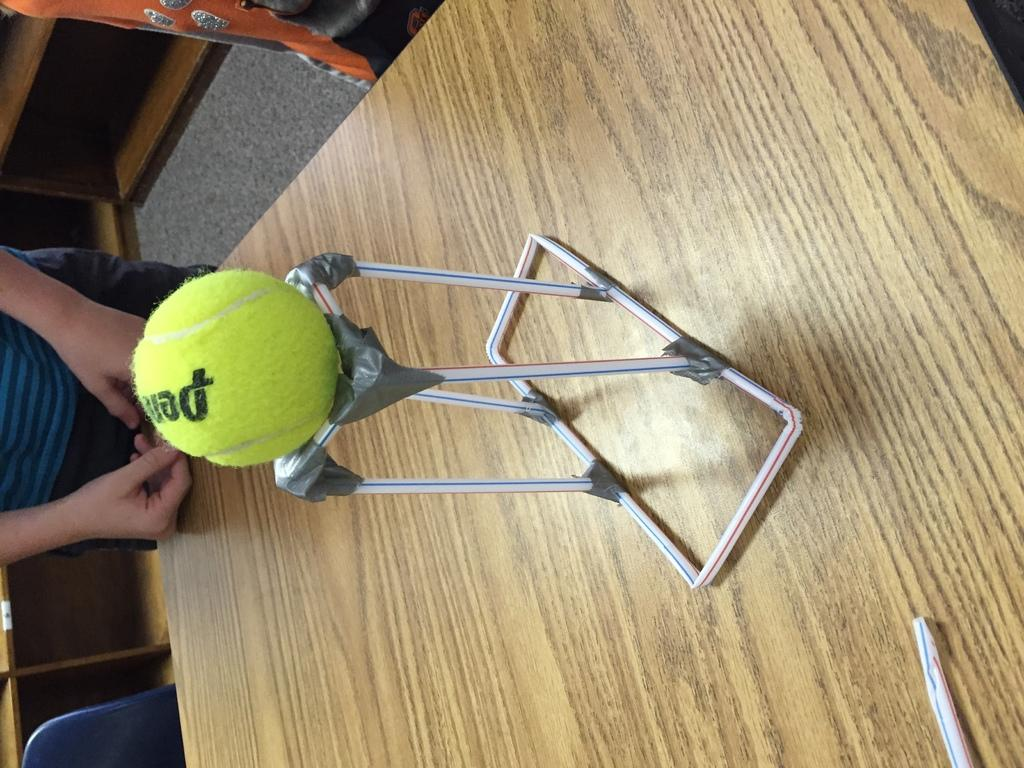What objects are hanging above the table in the image? There are straws and a tennis ball hanging above the table in the image. What type of furniture is on the left side of the image? There is a cupboard on the left side of the image. What type of flooring is present in the image? The floor has a carpet. What type of seating is visible in the image? There is a chair in the image. Is there a person in the image? Yes, a person is present in the image. What type of nut is being cracked by the person in the image? There is no nut present in the image, and the person is not shown cracking a nut. What type of camp is visible in the image? There is no camp present in the image; it is an indoor setting with a cupboard, table, and chair. 